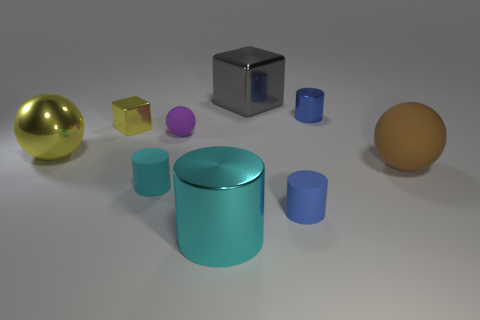Subtract all small metal cylinders. How many cylinders are left? 3 Subtract 1 cylinders. How many cylinders are left? 3 Subtract all spheres. How many objects are left? 6 Subtract all purple balls. How many balls are left? 2 Add 1 gray objects. How many objects exist? 10 Add 3 red shiny blocks. How many red shiny blocks exist? 3 Subtract 0 cyan cubes. How many objects are left? 9 Subtract all red cylinders. Subtract all yellow cubes. How many cylinders are left? 4 Subtract all yellow cylinders. How many brown balls are left? 1 Subtract all small cyan objects. Subtract all brown things. How many objects are left? 7 